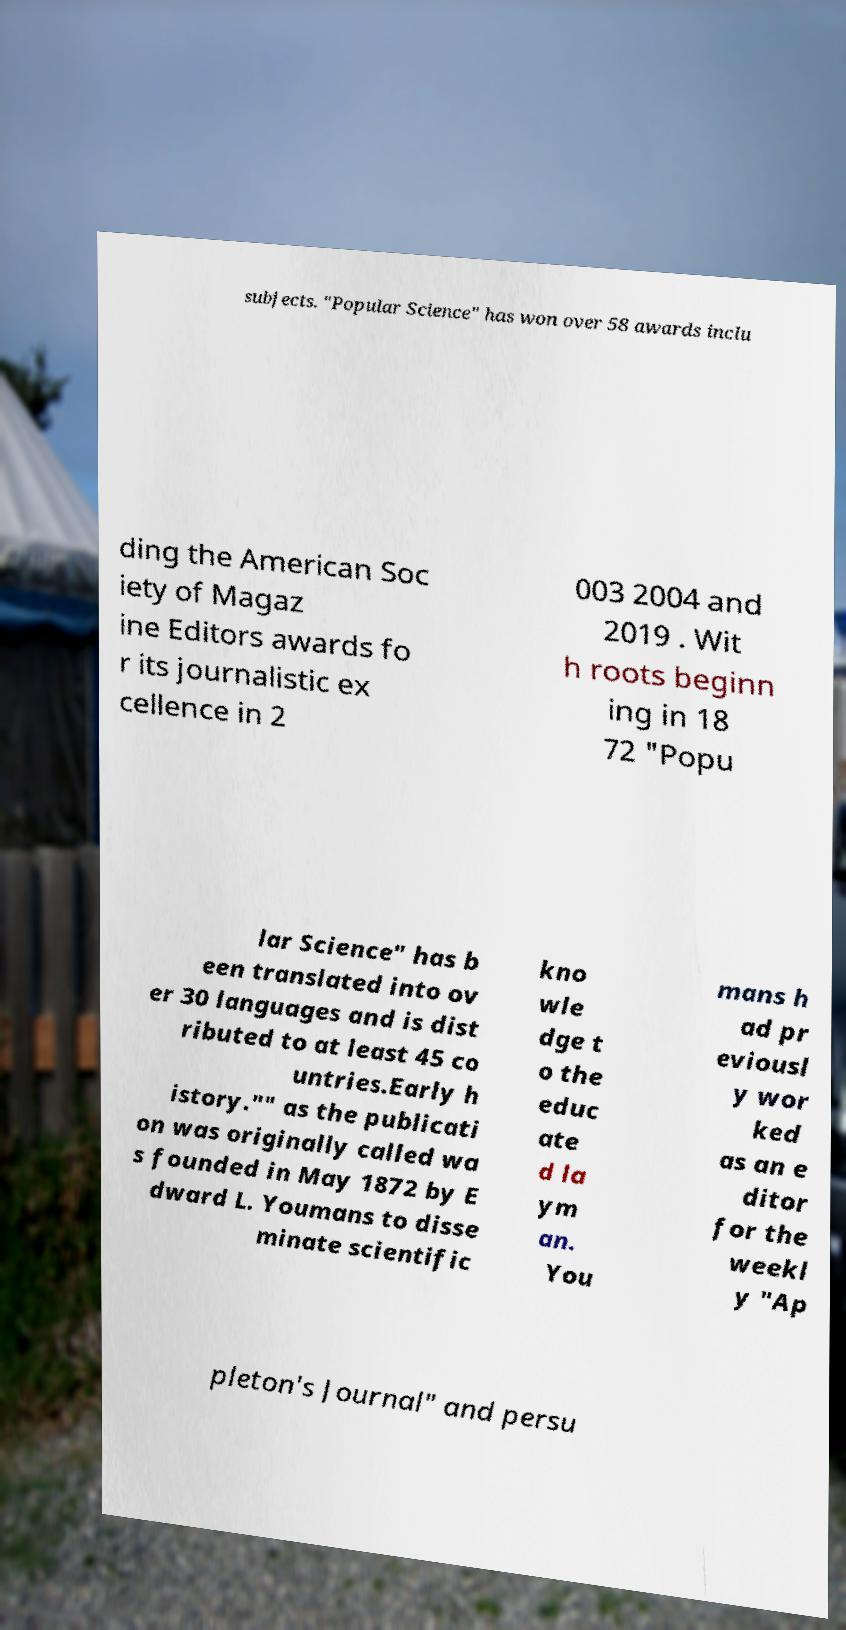I need the written content from this picture converted into text. Can you do that? subjects. "Popular Science" has won over 58 awards inclu ding the American Soc iety of Magaz ine Editors awards fo r its journalistic ex cellence in 2 003 2004 and 2019 . Wit h roots beginn ing in 18 72 "Popu lar Science" has b een translated into ov er 30 languages and is dist ributed to at least 45 co untries.Early h istory."" as the publicati on was originally called wa s founded in May 1872 by E dward L. Youmans to disse minate scientific kno wle dge t o the educ ate d la ym an. You mans h ad pr eviousl y wor ked as an e ditor for the weekl y "Ap pleton's Journal" and persu 